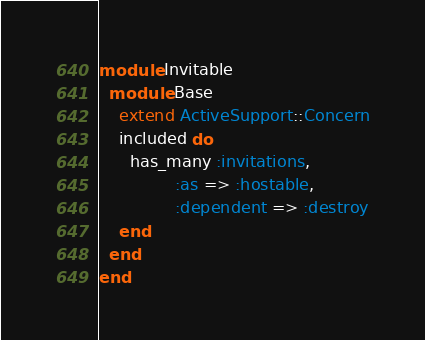Convert code to text. <code><loc_0><loc_0><loc_500><loc_500><_Ruby_>module Invitable
  module Base
    extend ActiveSupport::Concern
    included do
      has_many :invitations,
               :as => :hostable,
               :dependent => :destroy
    end
  end
end
</code> 